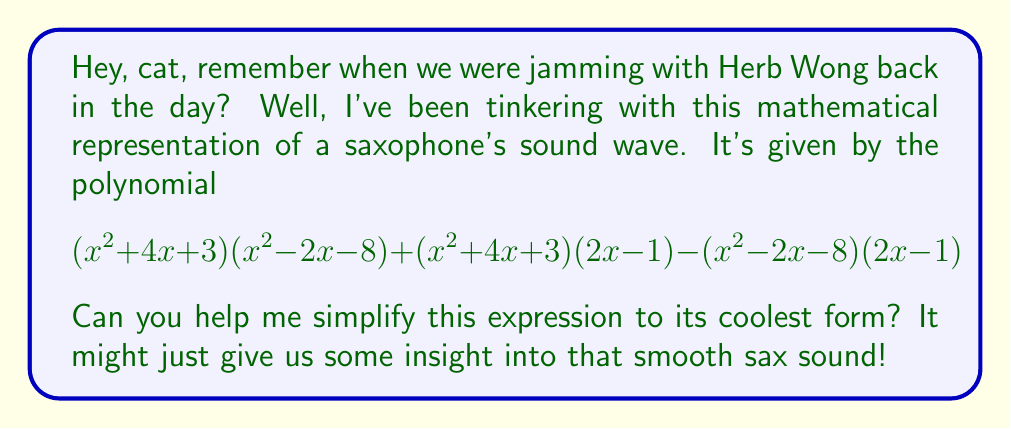Show me your answer to this math problem. Alright, let's break this down step-by-step, just like we'd dissect a jazz tune:

1) First, let's distribute the terms:
   $$(x^2 + 4x + 3)(x^2 - 2x - 8) + (x^2 + 4x + 3)(2x - 1) - (x^2 - 2x - 8)(2x - 1)$$

2) Let's call $(x^2 + 4x + 3) = A$, $(x^2 - 2x - 8) = B$, and $(2x - 1) = C$ for simplicity.
   So our expression becomes: $$AB + AC - BC$$

3) This is similar to the pattern $ab + ac - bc$, which can be factored as $a(b + c) - bc$.
   Using this pattern, our expression becomes:
   $$A(B + C) - BC$$

4) Now, let's substitute back the original expressions:
   $$(x^2 + 4x + 3)((x^2 - 2x - 8) + (2x - 1)) - (x^2 - 2x - 8)(2x - 1)$$

5) Simplify inside the second parentheses:
   $$(x^2 + 4x + 3)(x^2 - 1) - (x^2 - 2x - 8)(2x - 1)$$

6) Now, let's FOIL these terms:
   $(x^4 + 4x^3 + 3x^2 - x^2 - 4x - 3) - (2x^3 - x^2 - 4x^2 + 2x - 16x + 8)$

7) Combine like terms:
   $x^4 + 4x^3 + 2x^2 - 4x - 3 - 2x^3 + 5x^2 + 14x - 8$

8) Final simplification:
   $$x^4 + 2x^3 + 7x^2 + 10x - 11$$

And there you have it! That's our simplified polynomial, representing the essence of that smooth sax sound.
Answer: $$x^4 + 2x^3 + 7x^2 + 10x - 11$$ 